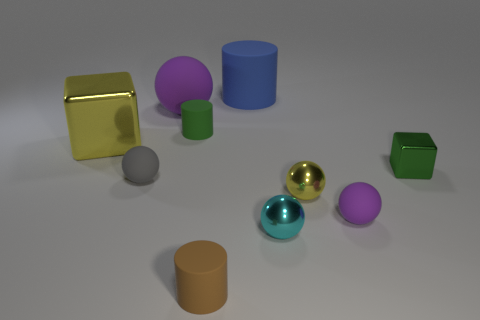How many other things are there of the same material as the small cyan object?
Offer a very short reply. 3. Are there fewer gray balls in front of the cyan metallic sphere than tiny cylinders on the right side of the small yellow thing?
Your response must be concise. No. What is the color of the tiny metal object that is the same shape as the large yellow thing?
Your response must be concise. Green. There is a purple object on the left side of the yellow sphere; is it the same size as the small gray thing?
Provide a short and direct response. No. Is the number of yellow blocks behind the large purple sphere less than the number of large blue rubber cylinders?
Provide a short and direct response. Yes. There is a yellow cube that is to the left of the large rubber thing left of the blue rubber cylinder; what size is it?
Offer a very short reply. Large. Is the number of big blue cylinders less than the number of large brown rubber things?
Ensure brevity in your answer.  No. What material is the small thing that is both behind the small gray ball and to the left of the green metal cube?
Offer a very short reply. Rubber. There is a small rubber sphere to the right of the small brown matte object; are there any tiny spheres that are in front of it?
Offer a very short reply. Yes. What number of things are either large matte cubes or spheres?
Provide a short and direct response. 5. 